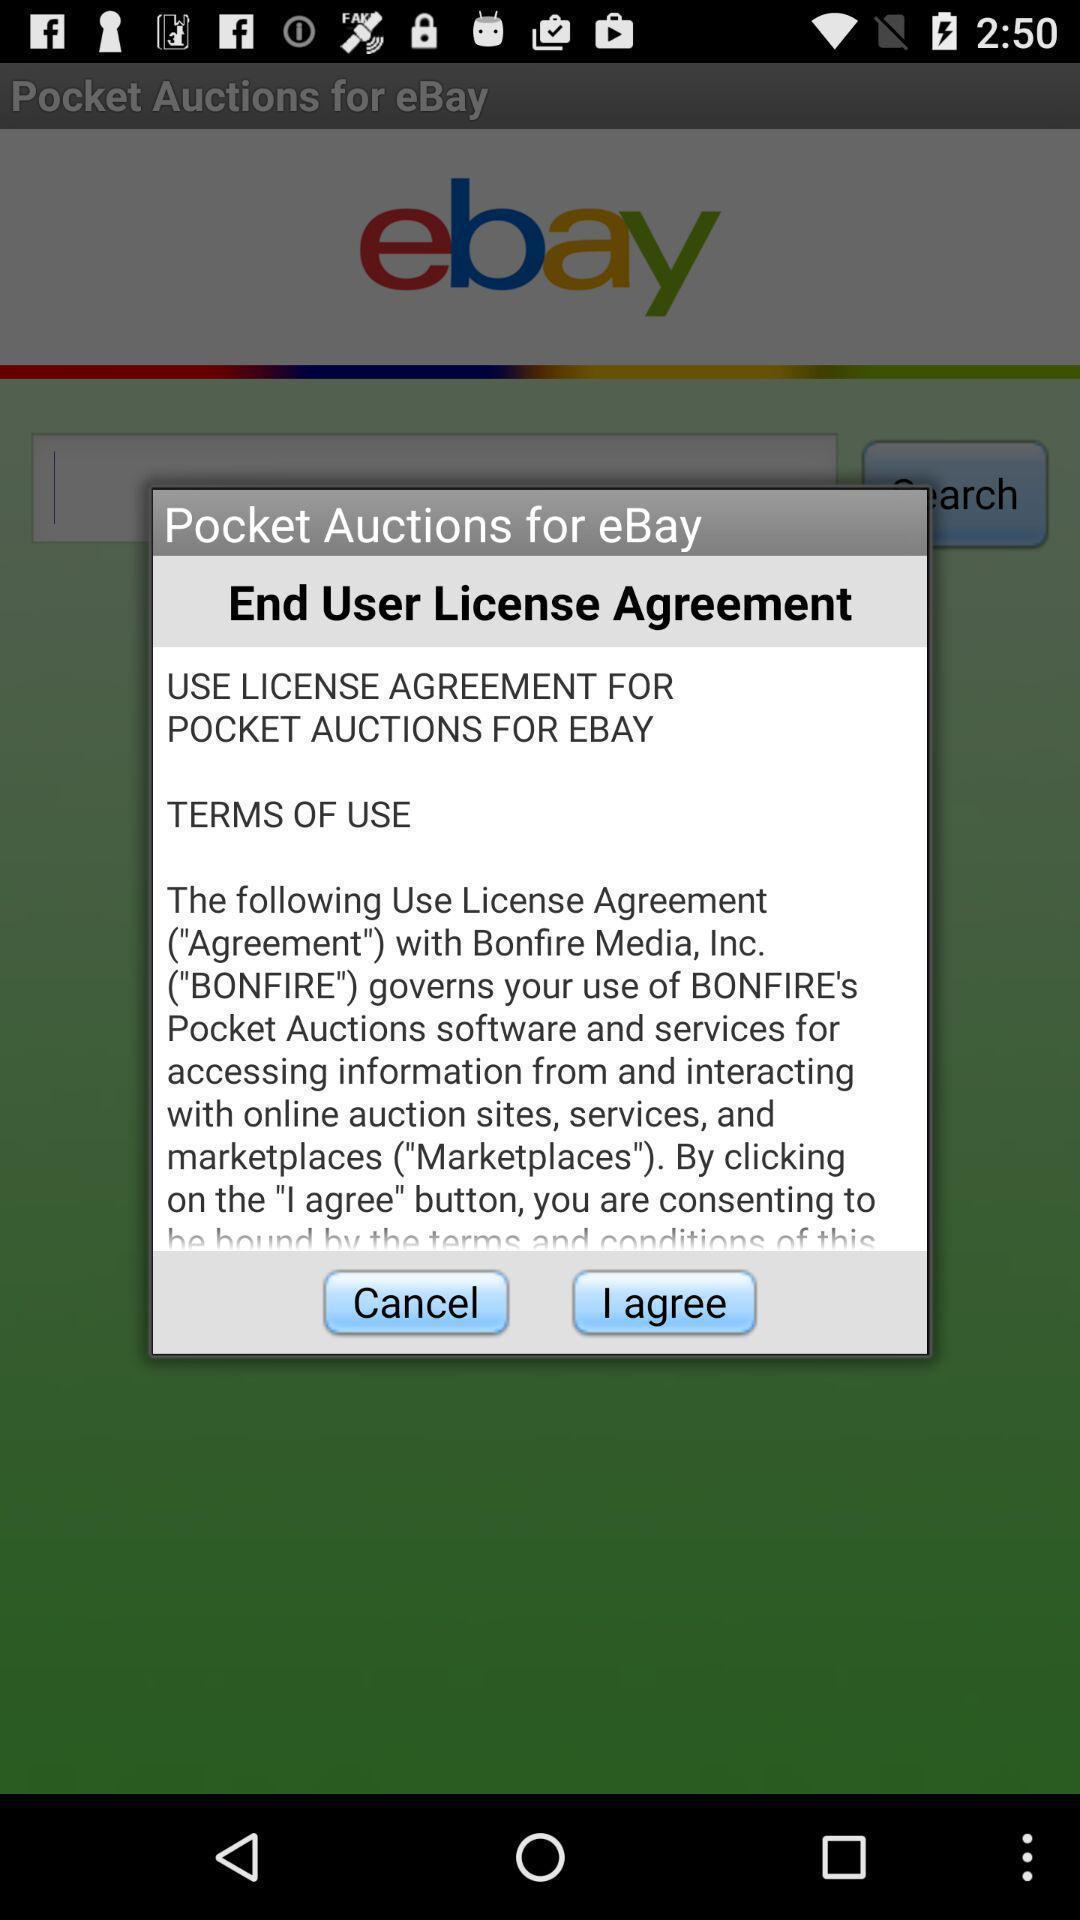Provide a textual representation of this image. Push up showing for shopping app. 